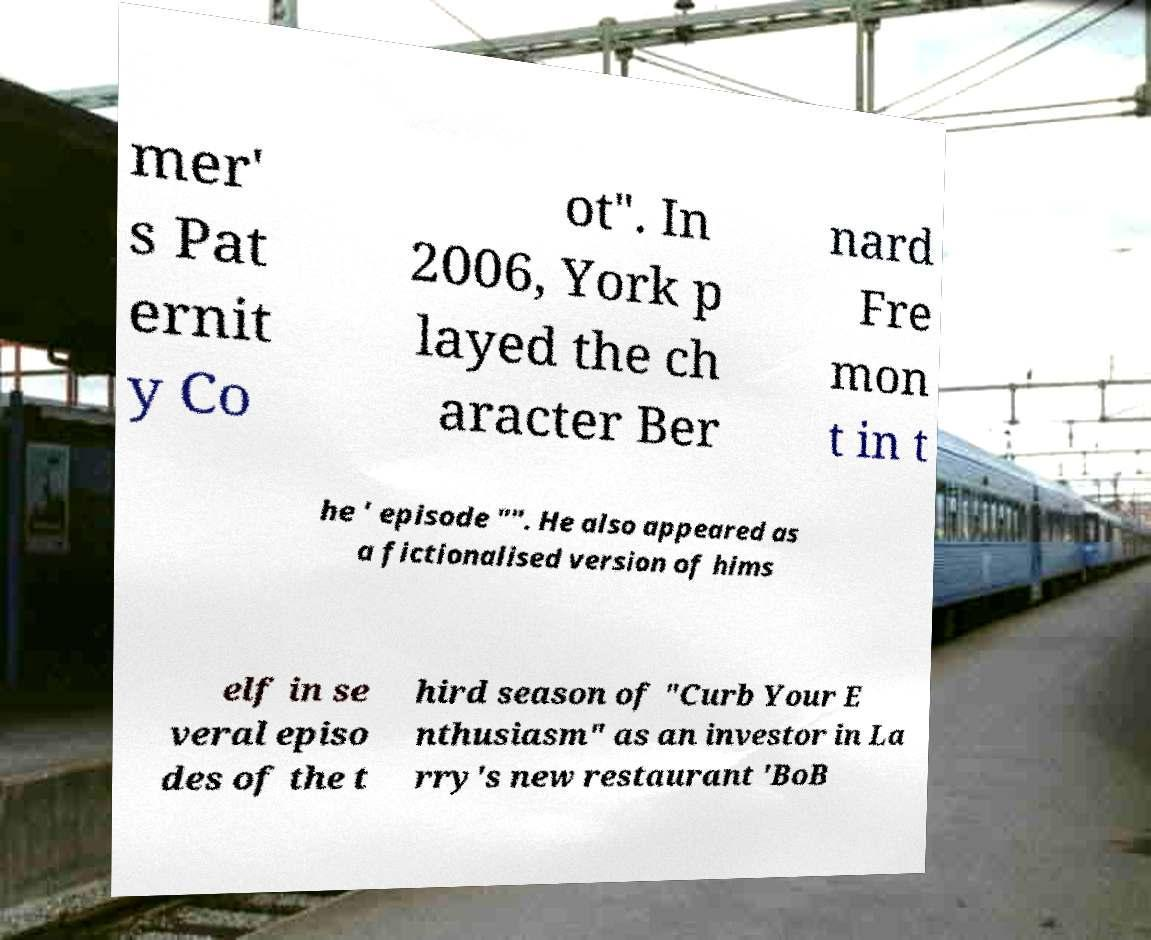For documentation purposes, I need the text within this image transcribed. Could you provide that? mer' s Pat ernit y Co ot". In 2006, York p layed the ch aracter Ber nard Fre mon t in t he ' episode "". He also appeared as a fictionalised version of hims elf in se veral episo des of the t hird season of "Curb Your E nthusiasm" as an investor in La rry's new restaurant 'BoB 